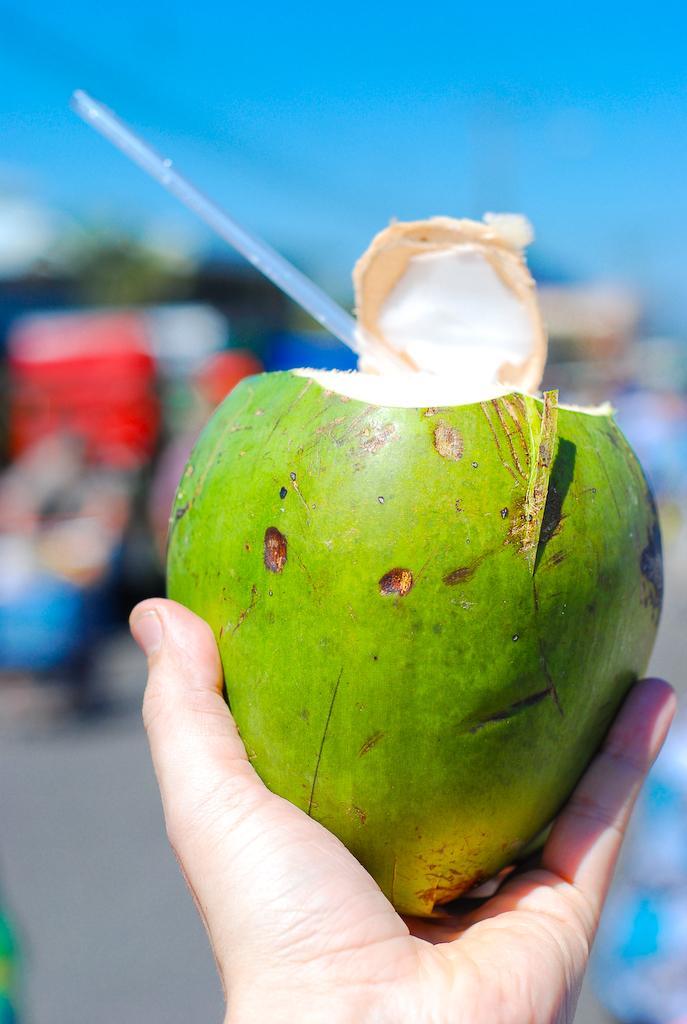In one or two sentences, can you explain what this image depicts? In this image we can see a hand of a person holding a coconut with a straw on it and the background is blurred. 